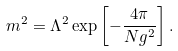<formula> <loc_0><loc_0><loc_500><loc_500>m ^ { 2 } = \Lambda ^ { 2 } \exp \left [ - \frac { 4 \pi } { N g ^ { 2 } } \right ] .</formula> 